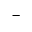Convert formula to latex. <formula><loc_0><loc_0><loc_500><loc_500>^ { - }</formula> 